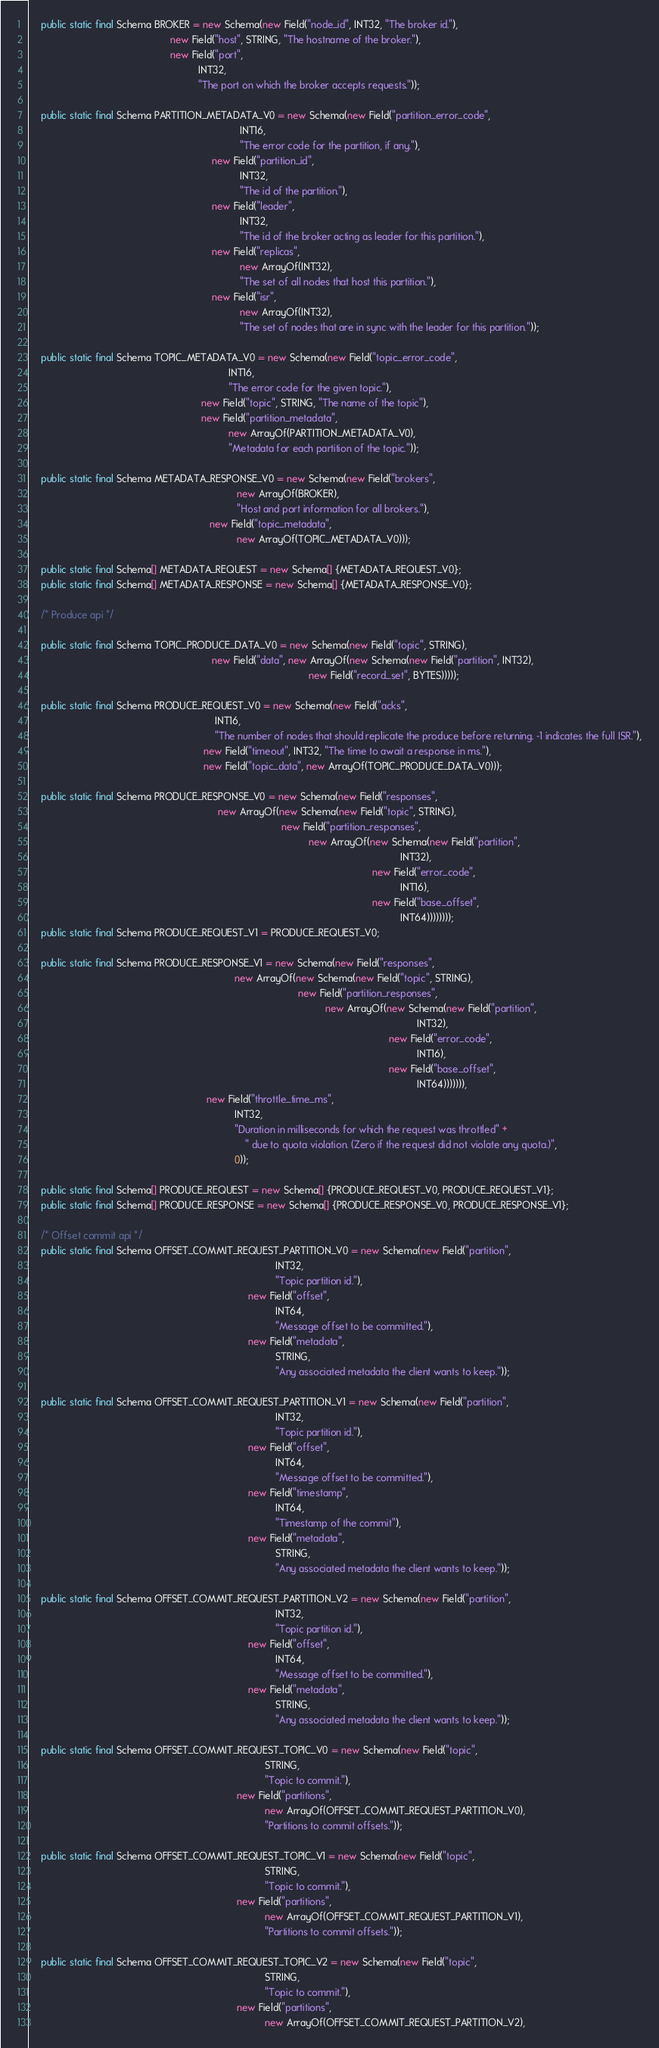Convert code to text. <code><loc_0><loc_0><loc_500><loc_500><_Java_>    public static final Schema BROKER = new Schema(new Field("node_id", INT32, "The broker id."),
                                                   new Field("host", STRING, "The hostname of the broker."),
                                                   new Field("port",
                                                             INT32,
                                                             "The port on which the broker accepts requests."));

    public static final Schema PARTITION_METADATA_V0 = new Schema(new Field("partition_error_code",
                                                                            INT16,
                                                                            "The error code for the partition, if any."),
                                                                  new Field("partition_id",
                                                                            INT32,
                                                                            "The id of the partition."),
                                                                  new Field("leader",
                                                                            INT32,
                                                                            "The id of the broker acting as leader for this partition."),
                                                                  new Field("replicas",
                                                                            new ArrayOf(INT32),
                                                                            "The set of all nodes that host this partition."),
                                                                  new Field("isr",
                                                                            new ArrayOf(INT32),
                                                                            "The set of nodes that are in sync with the leader for this partition."));

    public static final Schema TOPIC_METADATA_V0 = new Schema(new Field("topic_error_code",
                                                                        INT16,
                                                                        "The error code for the given topic."),
                                                              new Field("topic", STRING, "The name of the topic"),
                                                              new Field("partition_metadata",
                                                                        new ArrayOf(PARTITION_METADATA_V0),
                                                                        "Metadata for each partition of the topic."));

    public static final Schema METADATA_RESPONSE_V0 = new Schema(new Field("brokers",
                                                                           new ArrayOf(BROKER),
                                                                           "Host and port information for all brokers."),
                                                                 new Field("topic_metadata",
                                                                           new ArrayOf(TOPIC_METADATA_V0)));

    public static final Schema[] METADATA_REQUEST = new Schema[] {METADATA_REQUEST_V0};
    public static final Schema[] METADATA_RESPONSE = new Schema[] {METADATA_RESPONSE_V0};

    /* Produce api */

    public static final Schema TOPIC_PRODUCE_DATA_V0 = new Schema(new Field("topic", STRING),
                                                                  new Field("data", new ArrayOf(new Schema(new Field("partition", INT32),
                                                                                                     new Field("record_set", BYTES)))));

    public static final Schema PRODUCE_REQUEST_V0 = new Schema(new Field("acks",
                                                                   INT16,
                                                                   "The number of nodes that should replicate the produce before returning. -1 indicates the full ISR."),
                                                               new Field("timeout", INT32, "The time to await a response in ms."),
                                                               new Field("topic_data", new ArrayOf(TOPIC_PRODUCE_DATA_V0)));

    public static final Schema PRODUCE_RESPONSE_V0 = new Schema(new Field("responses",
                                                                    new ArrayOf(new Schema(new Field("topic", STRING),
                                                                                           new Field("partition_responses",
                                                                                                     new ArrayOf(new Schema(new Field("partition",
                                                                                                                                      INT32),
                                                                                                                            new Field("error_code",
                                                                                                                                      INT16),
                                                                                                                            new Field("base_offset",
                                                                                                                                      INT64))))))));
    public static final Schema PRODUCE_REQUEST_V1 = PRODUCE_REQUEST_V0;

    public static final Schema PRODUCE_RESPONSE_V1 = new Schema(new Field("responses",
                                                                          new ArrayOf(new Schema(new Field("topic", STRING),
                                                                                                 new Field("partition_responses",
                                                                                                           new ArrayOf(new Schema(new Field("partition",
                                                                                                                                            INT32),
                                                                                                                                  new Field("error_code",
                                                                                                                                            INT16),
                                                                                                                                  new Field("base_offset",
                                                                                                                                            INT64))))))),
                                                                new Field("throttle_time_ms",
                                                                          INT32,
                                                                          "Duration in milliseconds for which the request was throttled" +
                                                                              " due to quota violation. (Zero if the request did not violate any quota.)",
                                                                          0));

    public static final Schema[] PRODUCE_REQUEST = new Schema[] {PRODUCE_REQUEST_V0, PRODUCE_REQUEST_V1};
    public static final Schema[] PRODUCE_RESPONSE = new Schema[] {PRODUCE_RESPONSE_V0, PRODUCE_RESPONSE_V1};

    /* Offset commit api */
    public static final Schema OFFSET_COMMIT_REQUEST_PARTITION_V0 = new Schema(new Field("partition",
                                                                                         INT32,
                                                                                         "Topic partition id."),
                                                                               new Field("offset",
                                                                                         INT64,
                                                                                         "Message offset to be committed."),
                                                                               new Field("metadata",
                                                                                         STRING,
                                                                                         "Any associated metadata the client wants to keep."));

    public static final Schema OFFSET_COMMIT_REQUEST_PARTITION_V1 = new Schema(new Field("partition",
                                                                                         INT32,
                                                                                         "Topic partition id."),
                                                                               new Field("offset",
                                                                                         INT64,
                                                                                         "Message offset to be committed."),
                                                                               new Field("timestamp",
                                                                                         INT64,
                                                                                         "Timestamp of the commit"),
                                                                               new Field("metadata",
                                                                                         STRING,
                                                                                         "Any associated metadata the client wants to keep."));

    public static final Schema OFFSET_COMMIT_REQUEST_PARTITION_V2 = new Schema(new Field("partition",
                                                                                         INT32,
                                                                                         "Topic partition id."),
                                                                               new Field("offset",
                                                                                         INT64,
                                                                                         "Message offset to be committed."),
                                                                               new Field("metadata",
                                                                                         STRING,
                                                                                         "Any associated metadata the client wants to keep."));

    public static final Schema OFFSET_COMMIT_REQUEST_TOPIC_V0 = new Schema(new Field("topic",
                                                                                     STRING,
                                                                                     "Topic to commit."),
                                                                           new Field("partitions",
                                                                                     new ArrayOf(OFFSET_COMMIT_REQUEST_PARTITION_V0),
                                                                                     "Partitions to commit offsets."));

    public static final Schema OFFSET_COMMIT_REQUEST_TOPIC_V1 = new Schema(new Field("topic",
                                                                                     STRING,
                                                                                     "Topic to commit."),
                                                                           new Field("partitions",
                                                                                     new ArrayOf(OFFSET_COMMIT_REQUEST_PARTITION_V1),
                                                                                     "Partitions to commit offsets."));

    public static final Schema OFFSET_COMMIT_REQUEST_TOPIC_V2 = new Schema(new Field("topic",
                                                                                     STRING,
                                                                                     "Topic to commit."),
                                                                           new Field("partitions",
                                                                                     new ArrayOf(OFFSET_COMMIT_REQUEST_PARTITION_V2),</code> 